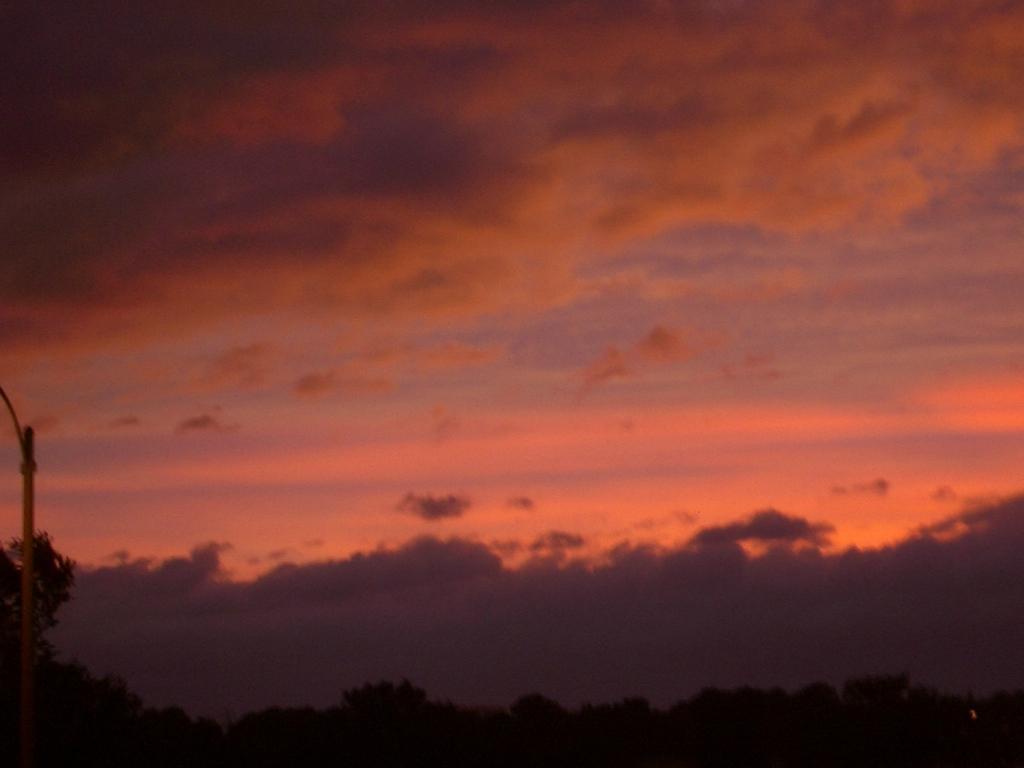What can be seen in the background of the image? There are groups of trees in the background of the image. What is visible at the top of the image? The sky is visible at the top of the image. Where is the coal being stored in the image? There is no coal present in the image. What type of waste can be seen on the sidewalk in the image? There is no sidewalk or waste present in the image. 